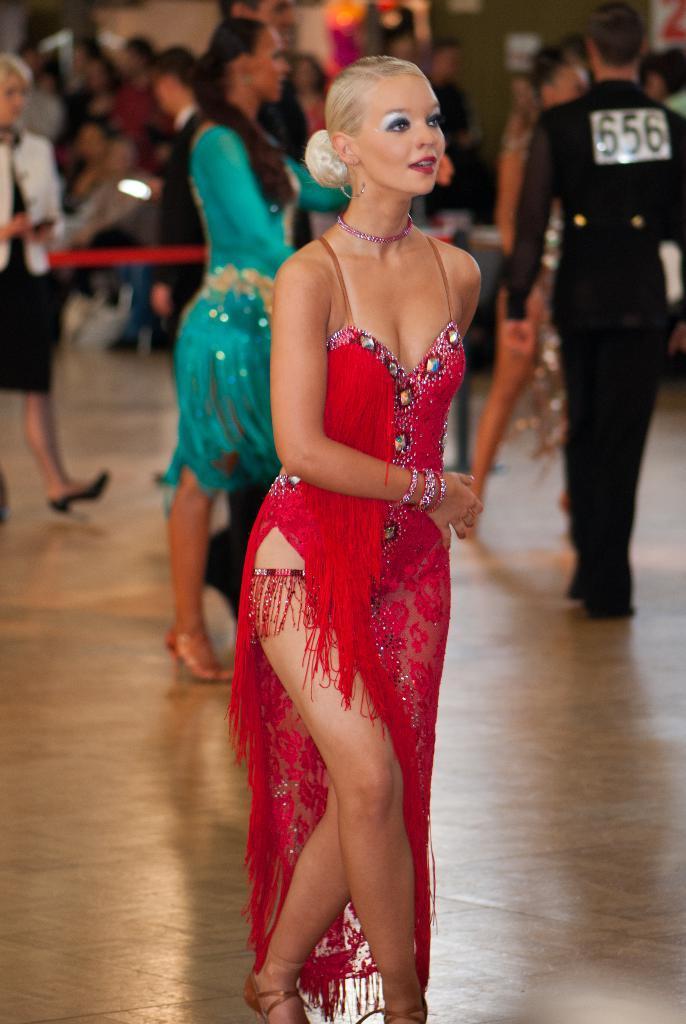Can you describe this image briefly? In the center of the image we can see one woman standing and she is smiling, which we can see on her face. And we can see she is in red color costume. In the background there is a wall, one banner, caution tape, few people are standing and a few other objects. 